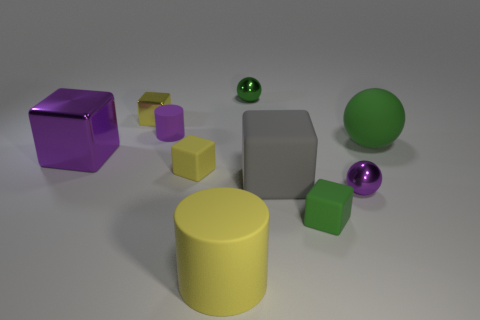Subtract all small yellow cubes. How many cubes are left? 3 Subtract all green cubes. How many cubes are left? 4 Subtract all blue blocks. Subtract all purple spheres. How many blocks are left? 5 Subtract all spheres. How many objects are left? 7 Subtract 0 blue blocks. How many objects are left? 10 Subtract all tiny purple things. Subtract all small purple matte cylinders. How many objects are left? 7 Add 4 small cubes. How many small cubes are left? 7 Add 8 blue metallic objects. How many blue metallic objects exist? 8 